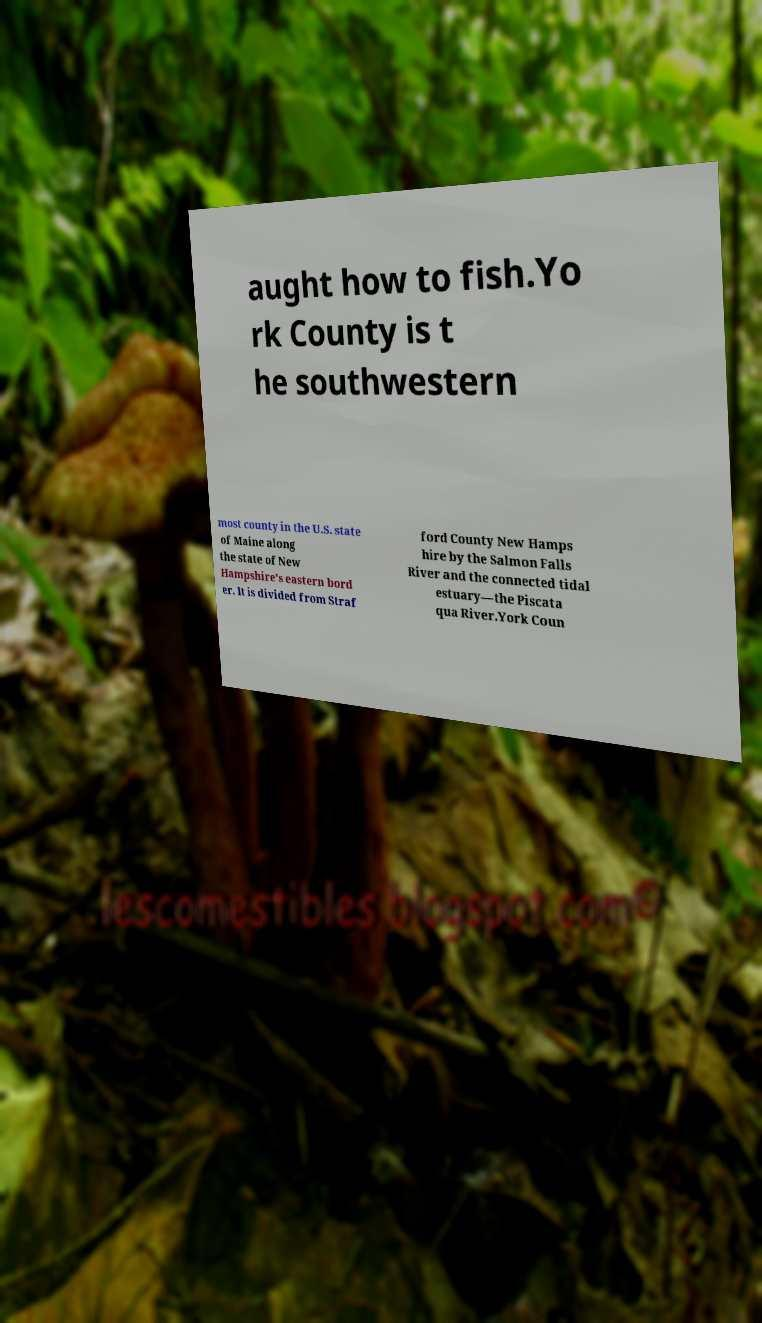There's text embedded in this image that I need extracted. Can you transcribe it verbatim? aught how to fish.Yo rk County is t he southwestern most county in the U.S. state of Maine along the state of New Hampshire's eastern bord er. It is divided from Straf ford County New Hamps hire by the Salmon Falls River and the connected tidal estuary—the Piscata qua River.York Coun 